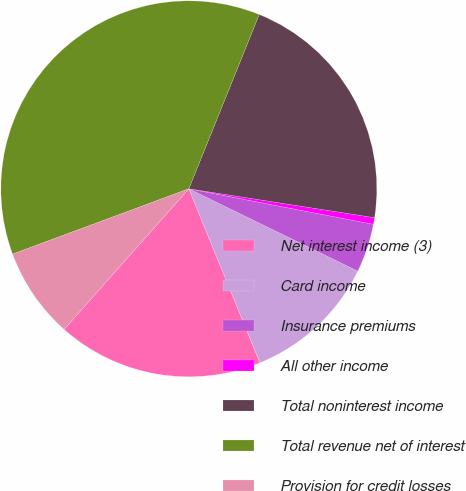Convert chart. <chart><loc_0><loc_0><loc_500><loc_500><pie_chart><fcel>Net interest income (3)<fcel>Card income<fcel>Insurance premiums<fcel>All other income<fcel>Total noninterest income<fcel>Total revenue net of interest<fcel>Provision for credit losses<nl><fcel>17.73%<fcel>11.61%<fcel>4.19%<fcel>0.57%<fcel>21.35%<fcel>36.76%<fcel>7.8%<nl></chart> 